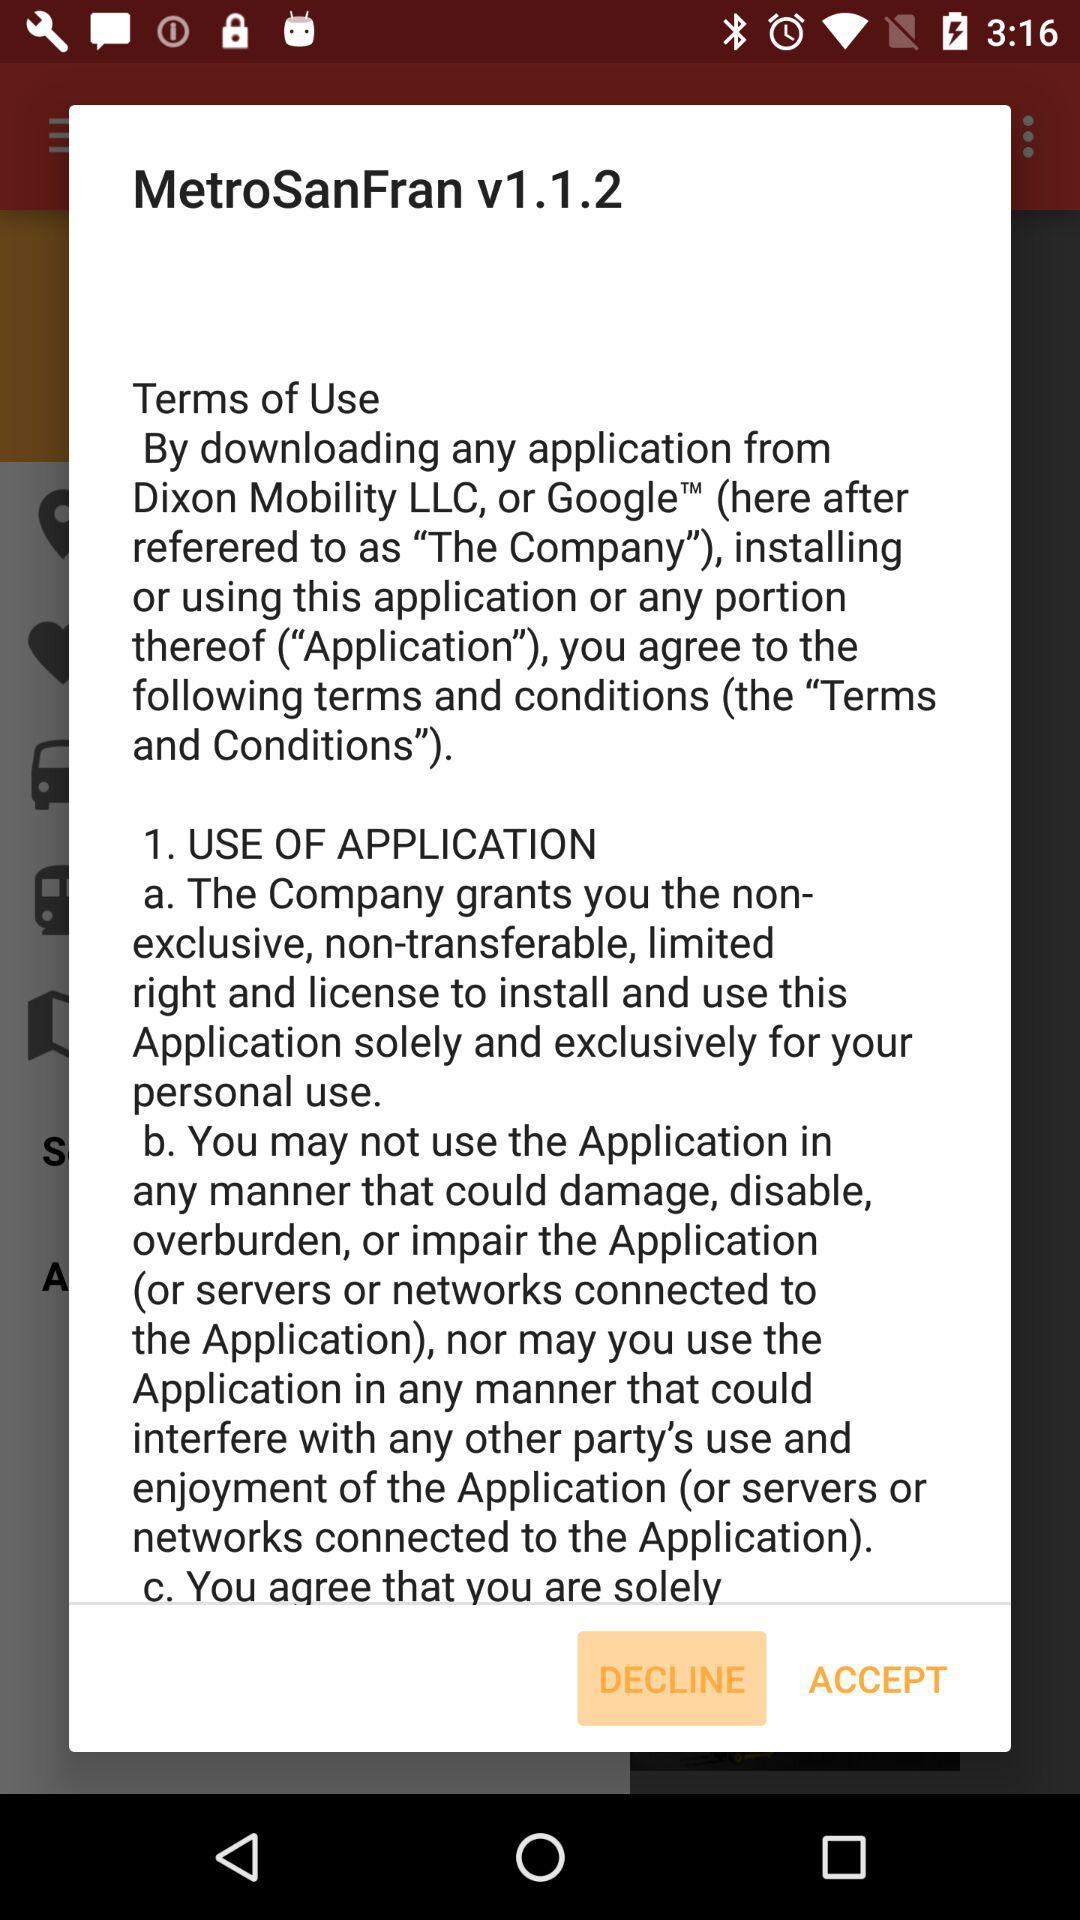Which version is this? This version is v1.1.2. 